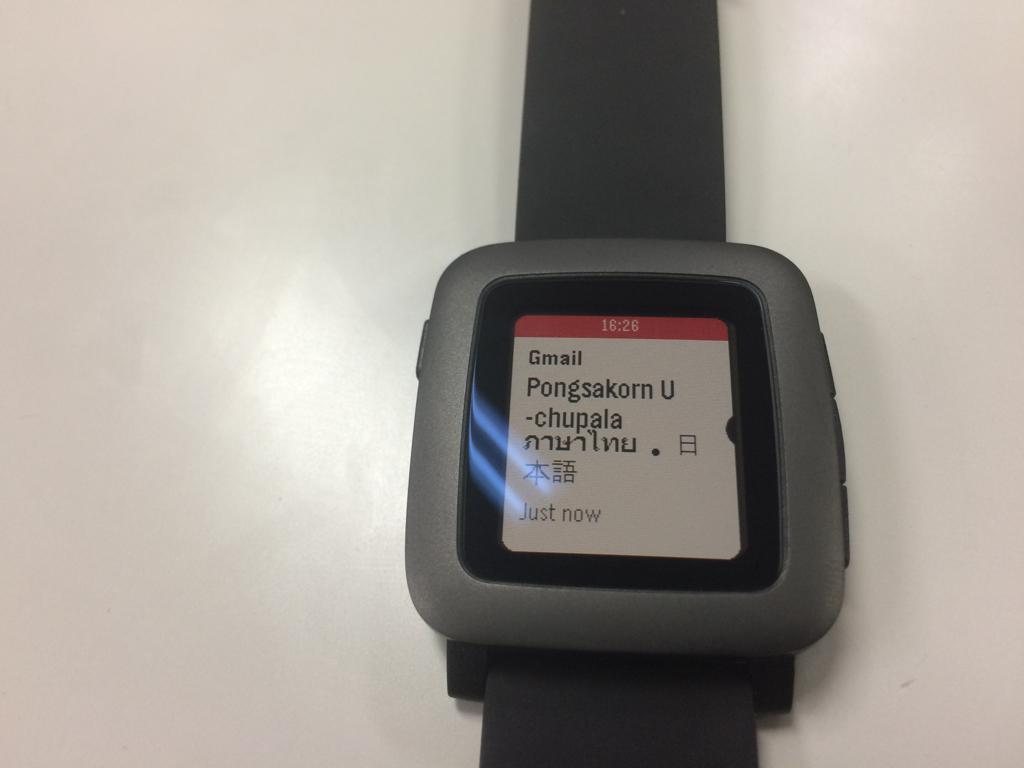<image>
Offer a succinct explanation of the picture presented. A watch open to a Gmail message that arrived just now. 